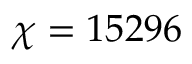Convert formula to latex. <formula><loc_0><loc_0><loc_500><loc_500>\chi = 1 5 2 9 6</formula> 